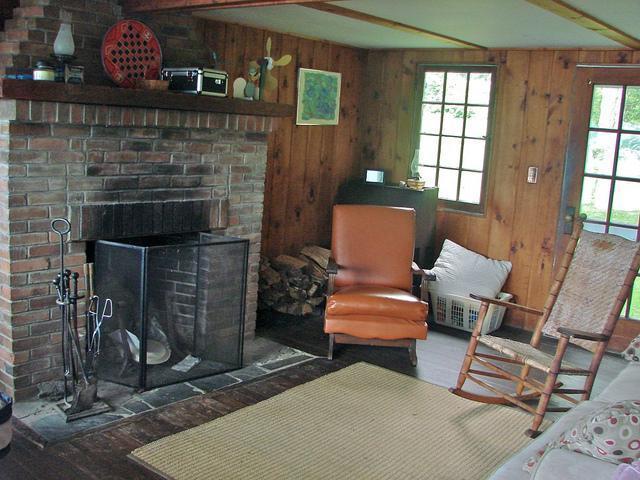How many couches are in the photo?
Give a very brief answer. 2. How many chairs are visible?
Give a very brief answer. 2. 